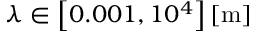<formula> <loc_0><loc_0><loc_500><loc_500>\lambda \in \left [ 0 . 0 0 1 , 1 0 ^ { 4 } \right ] \left [ { m } \right ]</formula> 